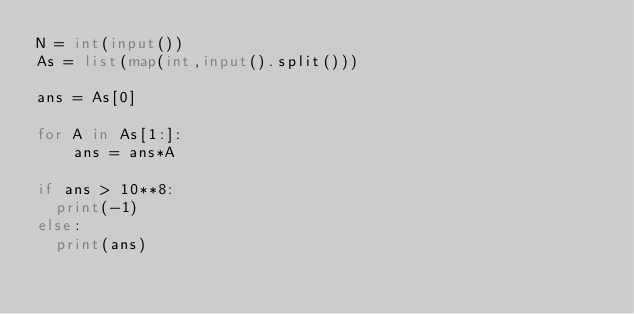<code> <loc_0><loc_0><loc_500><loc_500><_Python_>N = int(input())
As = list(map(int,input().split()))

ans = As[0]

for A in As[1:]:
    ans = ans*A

if ans > 10**8:
  print(-1)
else:
  print(ans)
</code> 